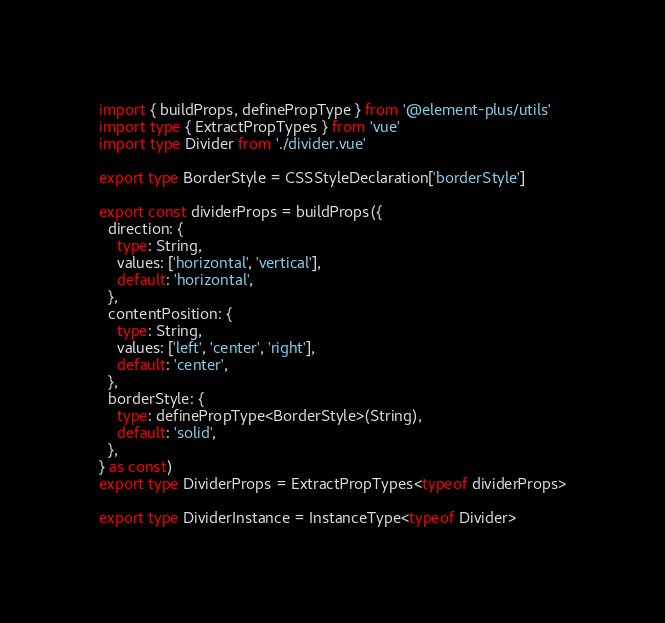<code> <loc_0><loc_0><loc_500><loc_500><_TypeScript_>import { buildProps, definePropType } from '@element-plus/utils'
import type { ExtractPropTypes } from 'vue'
import type Divider from './divider.vue'

export type BorderStyle = CSSStyleDeclaration['borderStyle']

export const dividerProps = buildProps({
  direction: {
    type: String,
    values: ['horizontal', 'vertical'],
    default: 'horizontal',
  },
  contentPosition: {
    type: String,
    values: ['left', 'center', 'right'],
    default: 'center',
  },
  borderStyle: {
    type: definePropType<BorderStyle>(String),
    default: 'solid',
  },
} as const)
export type DividerProps = ExtractPropTypes<typeof dividerProps>

export type DividerInstance = InstanceType<typeof Divider>
</code> 